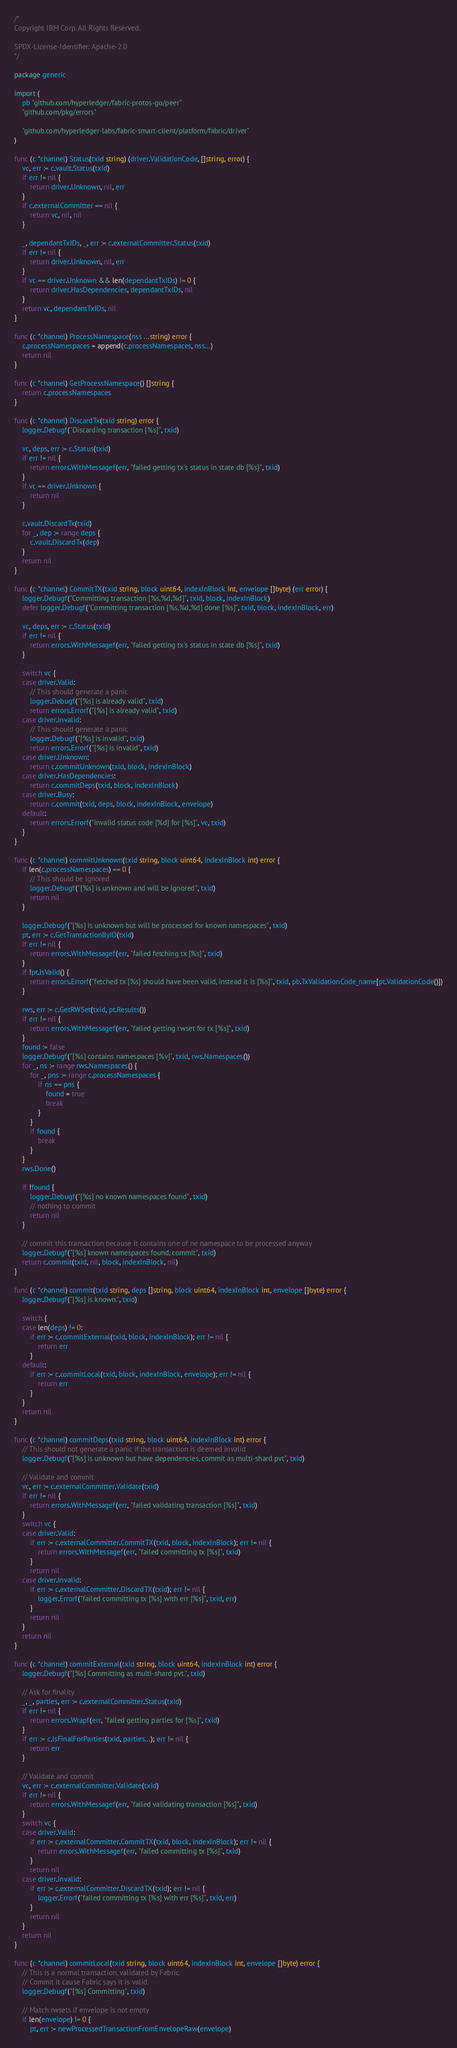Convert code to text. <code><loc_0><loc_0><loc_500><loc_500><_Go_>/*
Copyright IBM Corp. All Rights Reserved.

SPDX-License-Identifier: Apache-2.0
*/

package generic

import (
	pb "github.com/hyperledger/fabric-protos-go/peer"
	"github.com/pkg/errors"

	"github.com/hyperledger-labs/fabric-smart-client/platform/fabric/driver"
)

func (c *channel) Status(txid string) (driver.ValidationCode, []string, error) {
	vc, err := c.vault.Status(txid)
	if err != nil {
		return driver.Unknown, nil, err
	}
	if c.externalCommitter == nil {
		return vc, nil, nil
	}

	_, dependantTxIDs, _, err := c.externalCommitter.Status(txid)
	if err != nil {
		return driver.Unknown, nil, err
	}
	if vc == driver.Unknown && len(dependantTxIDs) != 0 {
		return driver.HasDependencies, dependantTxIDs, nil
	}
	return vc, dependantTxIDs, nil
}

func (c *channel) ProcessNamespace(nss ...string) error {
	c.processNamespaces = append(c.processNamespaces, nss...)
	return nil
}

func (c *channel) GetProcessNamespace() []string {
	return c.processNamespaces
}

func (c *channel) DiscardTx(txid string) error {
	logger.Debugf("Discarding transaction [%s]", txid)

	vc, deps, err := c.Status(txid)
	if err != nil {
		return errors.WithMessagef(err, "failed getting tx's status in state db [%s]", txid)
	}
	if vc == driver.Unknown {
		return nil
	}

	c.vault.DiscardTx(txid)
	for _, dep := range deps {
		c.vault.DiscardTx(dep)
	}
	return nil
}

func (c *channel) CommitTX(txid string, block uint64, indexInBlock int, envelope []byte) (err error) {
	logger.Debugf("Committing transaction [%s,%d,%d]", txid, block, indexInBlock)
	defer logger.Debugf("Committing transaction [%s,%d,%d] done [%s]", txid, block, indexInBlock, err)

	vc, deps, err := c.Status(txid)
	if err != nil {
		return errors.WithMessagef(err, "failed getting tx's status in state db [%s]", txid)
	}

	switch vc {
	case driver.Valid:
		// This should generate a panic
		logger.Debugf("[%s] is already valid", txid)
		return errors.Errorf("[%s] is already valid", txid)
	case driver.Invalid:
		// This should generate a panic
		logger.Debugf("[%s] is invalid", txid)
		return errors.Errorf("[%s] is invalid", txid)
	case driver.Unknown:
		return c.commitUnknown(txid, block, indexInBlock)
	case driver.HasDependencies:
		return c.commitDeps(txid, block, indexInBlock)
	case driver.Busy:
		return c.commit(txid, deps, block, indexInBlock, envelope)
	default:
		return errors.Errorf("invalid status code [%d] for [%s]", vc, txid)
	}
}

func (c *channel) commitUnknown(txid string, block uint64, indexInBlock int) error {
	if len(c.processNamespaces) == 0 {
		// This should be ignored
		logger.Debugf("[%s] is unknown and will be ignored", txid)
		return nil
	}

	logger.Debugf("[%s] is unknown but will be processed for known namespaces", txid)
	pt, err := c.GetTransactionByID(txid)
	if err != nil {
		return errors.WithMessagef(err, "failed fetching tx [%s]", txid)
	}
	if !pt.IsValid() {
		return errors.Errorf("fetched tx [%s] should have been valid, instead it is [%s]", txid, pb.TxValidationCode_name[pt.ValidationCode()])
	}

	rws, err := c.GetRWSet(txid, pt.Results())
	if err != nil {
		return errors.WithMessagef(err, "failed getting rwset for tx [%s]", txid)
	}
	found := false
	logger.Debugf("[%s] contains namespaces [%v]", txid, rws.Namespaces())
	for _, ns := range rws.Namespaces() {
		for _, pns := range c.processNamespaces {
			if ns == pns {
				found = true
				break
			}
		}
		if found {
			break
		}
	}
	rws.Done()

	if !found {
		logger.Debugf("[%s] no known namespaces found", txid)
		// nothing to commit
		return nil
	}

	// commit this transaction because it contains one of ne namespace to be processed anyway
	logger.Debugf("[%s] known namespaces found, commit", txid)
	return c.commit(txid, nil, block, indexInBlock, nil)
}

func (c *channel) commit(txid string, deps []string, block uint64, indexInBlock int, envelope []byte) error {
	logger.Debugf("[%s] is known.", txid)

	switch {
	case len(deps) != 0:
		if err := c.commitExternal(txid, block, indexInBlock); err != nil {
			return err
		}
	default:
		if err := c.commitLocal(txid, block, indexInBlock, envelope); err != nil {
			return err
		}
	}
	return nil
}

func (c *channel) commitDeps(txid string, block uint64, indexInBlock int) error {
	// This should not generate a panic if the transaction is deemed invalid
	logger.Debugf("[%s] is unknown but have dependencies, commit as multi-shard pvt", txid)

	// Validate and commit
	vc, err := c.externalCommitter.Validate(txid)
	if err != nil {
		return errors.WithMessagef(err, "failed validating transaction [%s]", txid)
	}
	switch vc {
	case driver.Valid:
		if err := c.externalCommitter.CommitTX(txid, block, indexInBlock); err != nil {
			return errors.WithMessagef(err, "failed committing tx [%s]", txid)
		}
		return nil
	case driver.Invalid:
		if err := c.externalCommitter.DiscardTX(txid); err != nil {
			logger.Errorf("failed committing tx [%s] with err [%s]", txid, err)
		}
		return nil
	}
	return nil
}

func (c *channel) commitExternal(txid string, block uint64, indexInBlock int) error {
	logger.Debugf("[%s] Committing as multi-shard pvt.", txid)

	// Ask for finality
	_, _, parties, err := c.externalCommitter.Status(txid)
	if err != nil {
		return errors.Wrapf(err, "failed getting parties for [%s]", txid)
	}
	if err := c.IsFinalForParties(txid, parties...); err != nil {
		return err
	}

	// Validate and commit
	vc, err := c.externalCommitter.Validate(txid)
	if err != nil {
		return errors.WithMessagef(err, "failed validating transaction [%s]", txid)
	}
	switch vc {
	case driver.Valid:
		if err := c.externalCommitter.CommitTX(txid, block, indexInBlock); err != nil {
			return errors.WithMessagef(err, "failed committing tx [%s]", txid)
		}
		return nil
	case driver.Invalid:
		if err := c.externalCommitter.DiscardTX(txid); err != nil {
			logger.Errorf("failed committing tx [%s] with err [%s]", txid, err)
		}
		return nil
	}
	return nil
}

func (c *channel) commitLocal(txid string, block uint64, indexInBlock int, envelope []byte) error {
	// This is a normal transaction, validated by Fabric.
	// Commit it cause Fabric says it is valid.
	logger.Debugf("[%s] Committing", txid)

	// Match rwsets if envelope is not empty
	if len(envelope) != 0 {
		pt, err := newProcessedTransactionFromEnvelopeRaw(envelope)</code> 